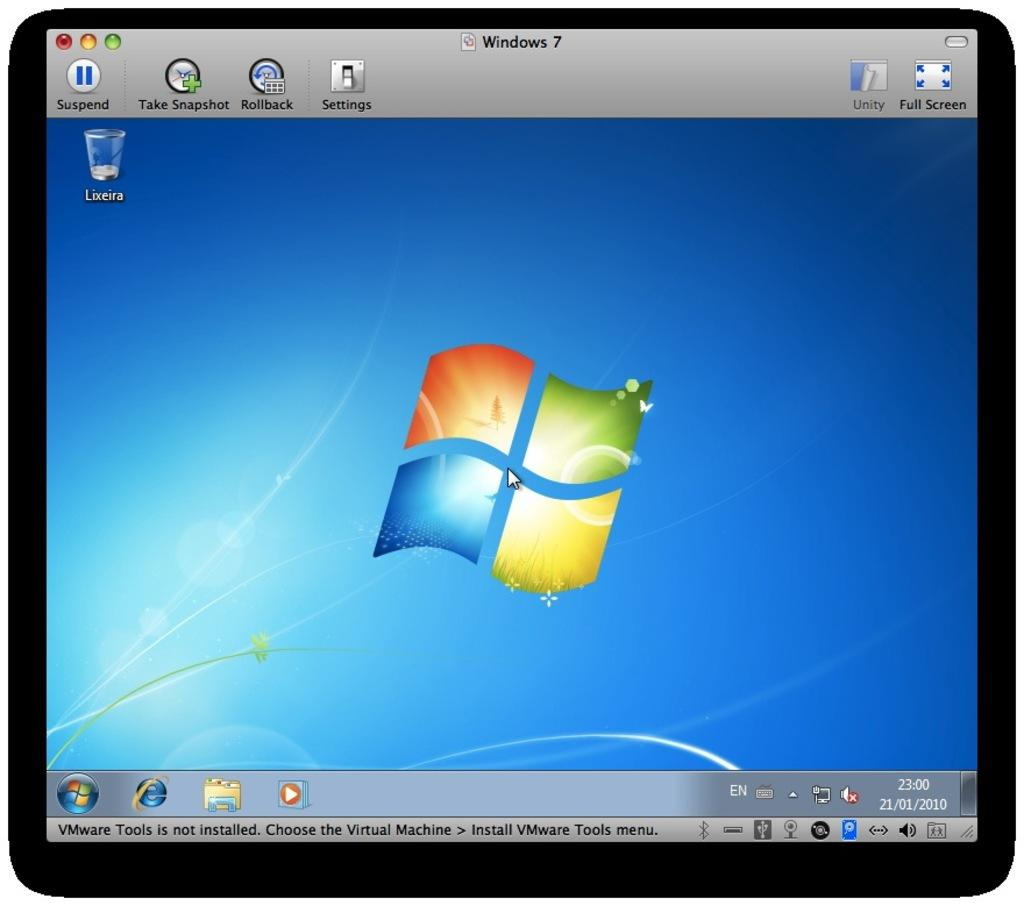What is the main object in the image? There is a monitor screen in the image. What can be seen on the monitor screen? There are symbols, text, and numbers on the monitor screen. What type of cheese is being used to fuel the watch in the image? There is no cheese, fuel, or watch present in the image. 